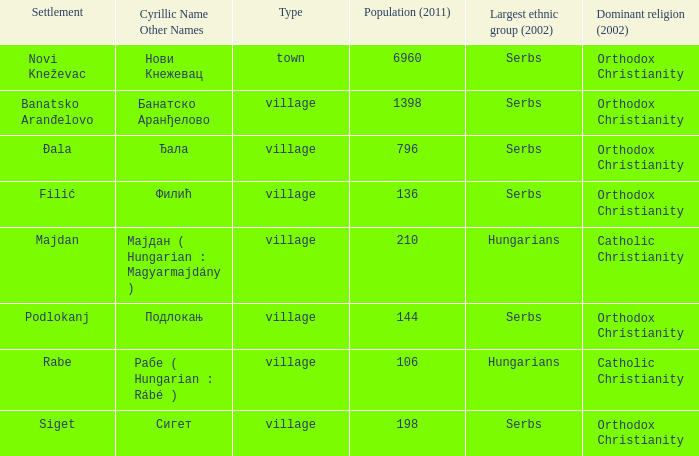How many dominant religions are in đala? 1.0. 